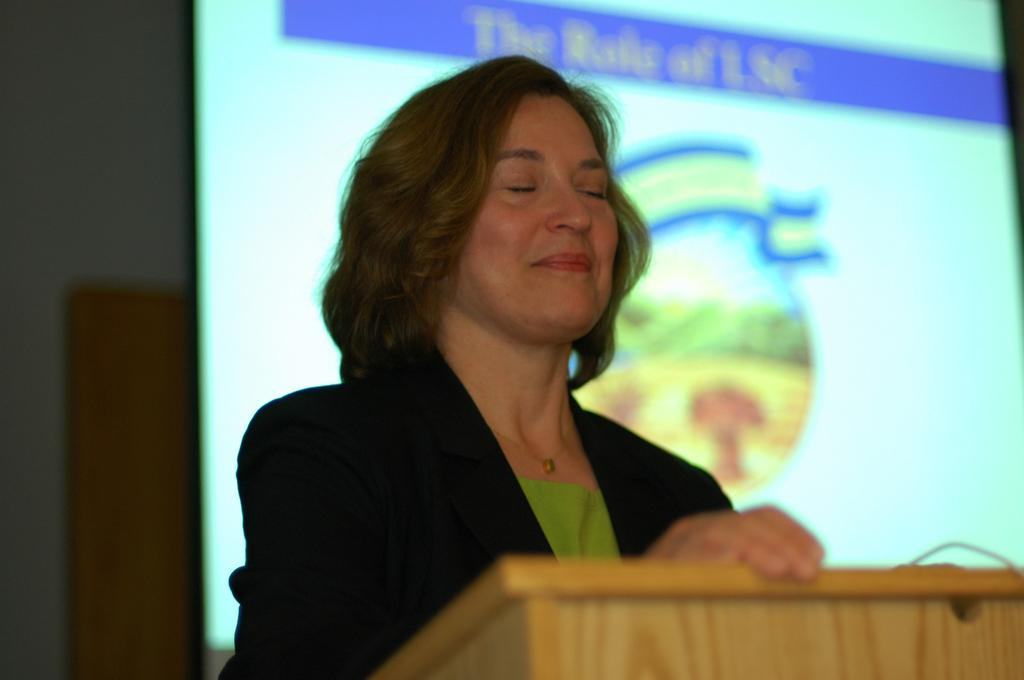What is the woman in the image doing? The woman is standing at the desk in the image. What can be seen behind the woman? There is a screen, a wall, and a door in the background of the image. What type of animals can be seen at the plantation in the image? There is no plantation or animals present in the image; it features a woman standing at a desk with a screen, wall, and door in the background. 